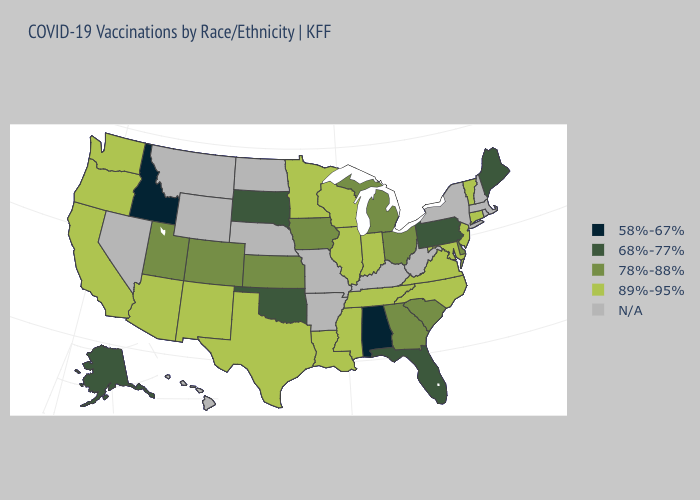Name the states that have a value in the range N/A?
Be succinct. Arkansas, Hawaii, Kentucky, Massachusetts, Missouri, Montana, Nebraska, Nevada, New Hampshire, New York, North Dakota, Rhode Island, West Virginia, Wyoming. Name the states that have a value in the range N/A?
Answer briefly. Arkansas, Hawaii, Kentucky, Massachusetts, Missouri, Montana, Nebraska, Nevada, New Hampshire, New York, North Dakota, Rhode Island, West Virginia, Wyoming. Which states have the lowest value in the USA?
Quick response, please. Alabama, Idaho. Among the states that border Alabama , which have the lowest value?
Short answer required. Florida. Name the states that have a value in the range 89%-95%?
Write a very short answer. Arizona, California, Connecticut, Illinois, Indiana, Louisiana, Maryland, Minnesota, Mississippi, New Jersey, New Mexico, North Carolina, Oregon, Tennessee, Texas, Vermont, Virginia, Washington, Wisconsin. How many symbols are there in the legend?
Write a very short answer. 5. Name the states that have a value in the range 89%-95%?
Write a very short answer. Arizona, California, Connecticut, Illinois, Indiana, Louisiana, Maryland, Minnesota, Mississippi, New Jersey, New Mexico, North Carolina, Oregon, Tennessee, Texas, Vermont, Virginia, Washington, Wisconsin. Does Alabama have the lowest value in the USA?
Be succinct. Yes. Name the states that have a value in the range N/A?
Short answer required. Arkansas, Hawaii, Kentucky, Massachusetts, Missouri, Montana, Nebraska, Nevada, New Hampshire, New York, North Dakota, Rhode Island, West Virginia, Wyoming. Name the states that have a value in the range N/A?
Keep it brief. Arkansas, Hawaii, Kentucky, Massachusetts, Missouri, Montana, Nebraska, Nevada, New Hampshire, New York, North Dakota, Rhode Island, West Virginia, Wyoming. Name the states that have a value in the range 68%-77%?
Concise answer only. Alaska, Florida, Maine, Oklahoma, Pennsylvania, South Dakota. Name the states that have a value in the range 78%-88%?
Be succinct. Colorado, Delaware, Georgia, Iowa, Kansas, Michigan, Ohio, South Carolina, Utah. Name the states that have a value in the range 68%-77%?
Quick response, please. Alaska, Florida, Maine, Oklahoma, Pennsylvania, South Dakota. 